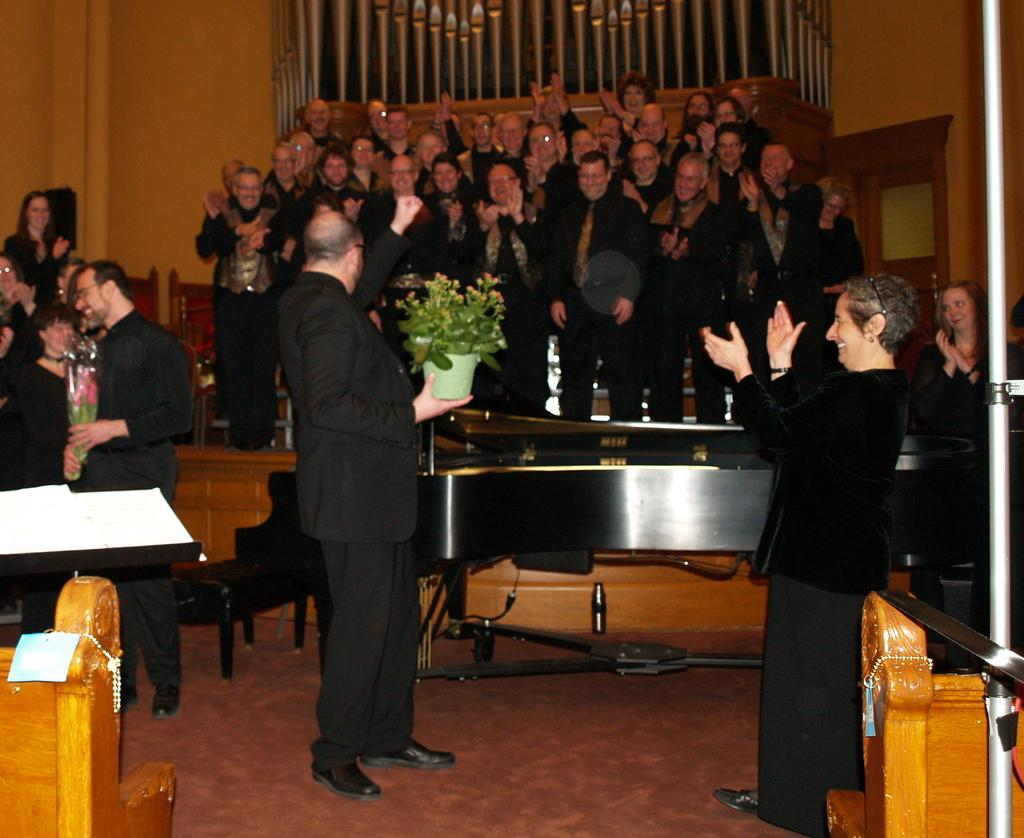How many people are in the image? There is a group of persons in the image. What is one of the persons holding? One man is holding a plant pot. What can be seen in the background of the image? There is a wall in the background of the image. What type of underwear is the man wearing in the image? There is no information about the man's underwear in the image, so it cannot be determined. 